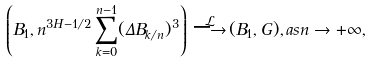Convert formula to latex. <formula><loc_0><loc_0><loc_500><loc_500>\left ( B _ { 1 } , n ^ { 3 H - 1 / 2 } \sum _ { k = 0 } ^ { n - 1 } ( \Delta B _ { k / n } ) ^ { 3 } \right ) \, { \stackrel { \mathcal { L } } { \longrightarrow } } \, ( B _ { 1 } , G ) , a s n \rightarrow + \infty ,</formula> 